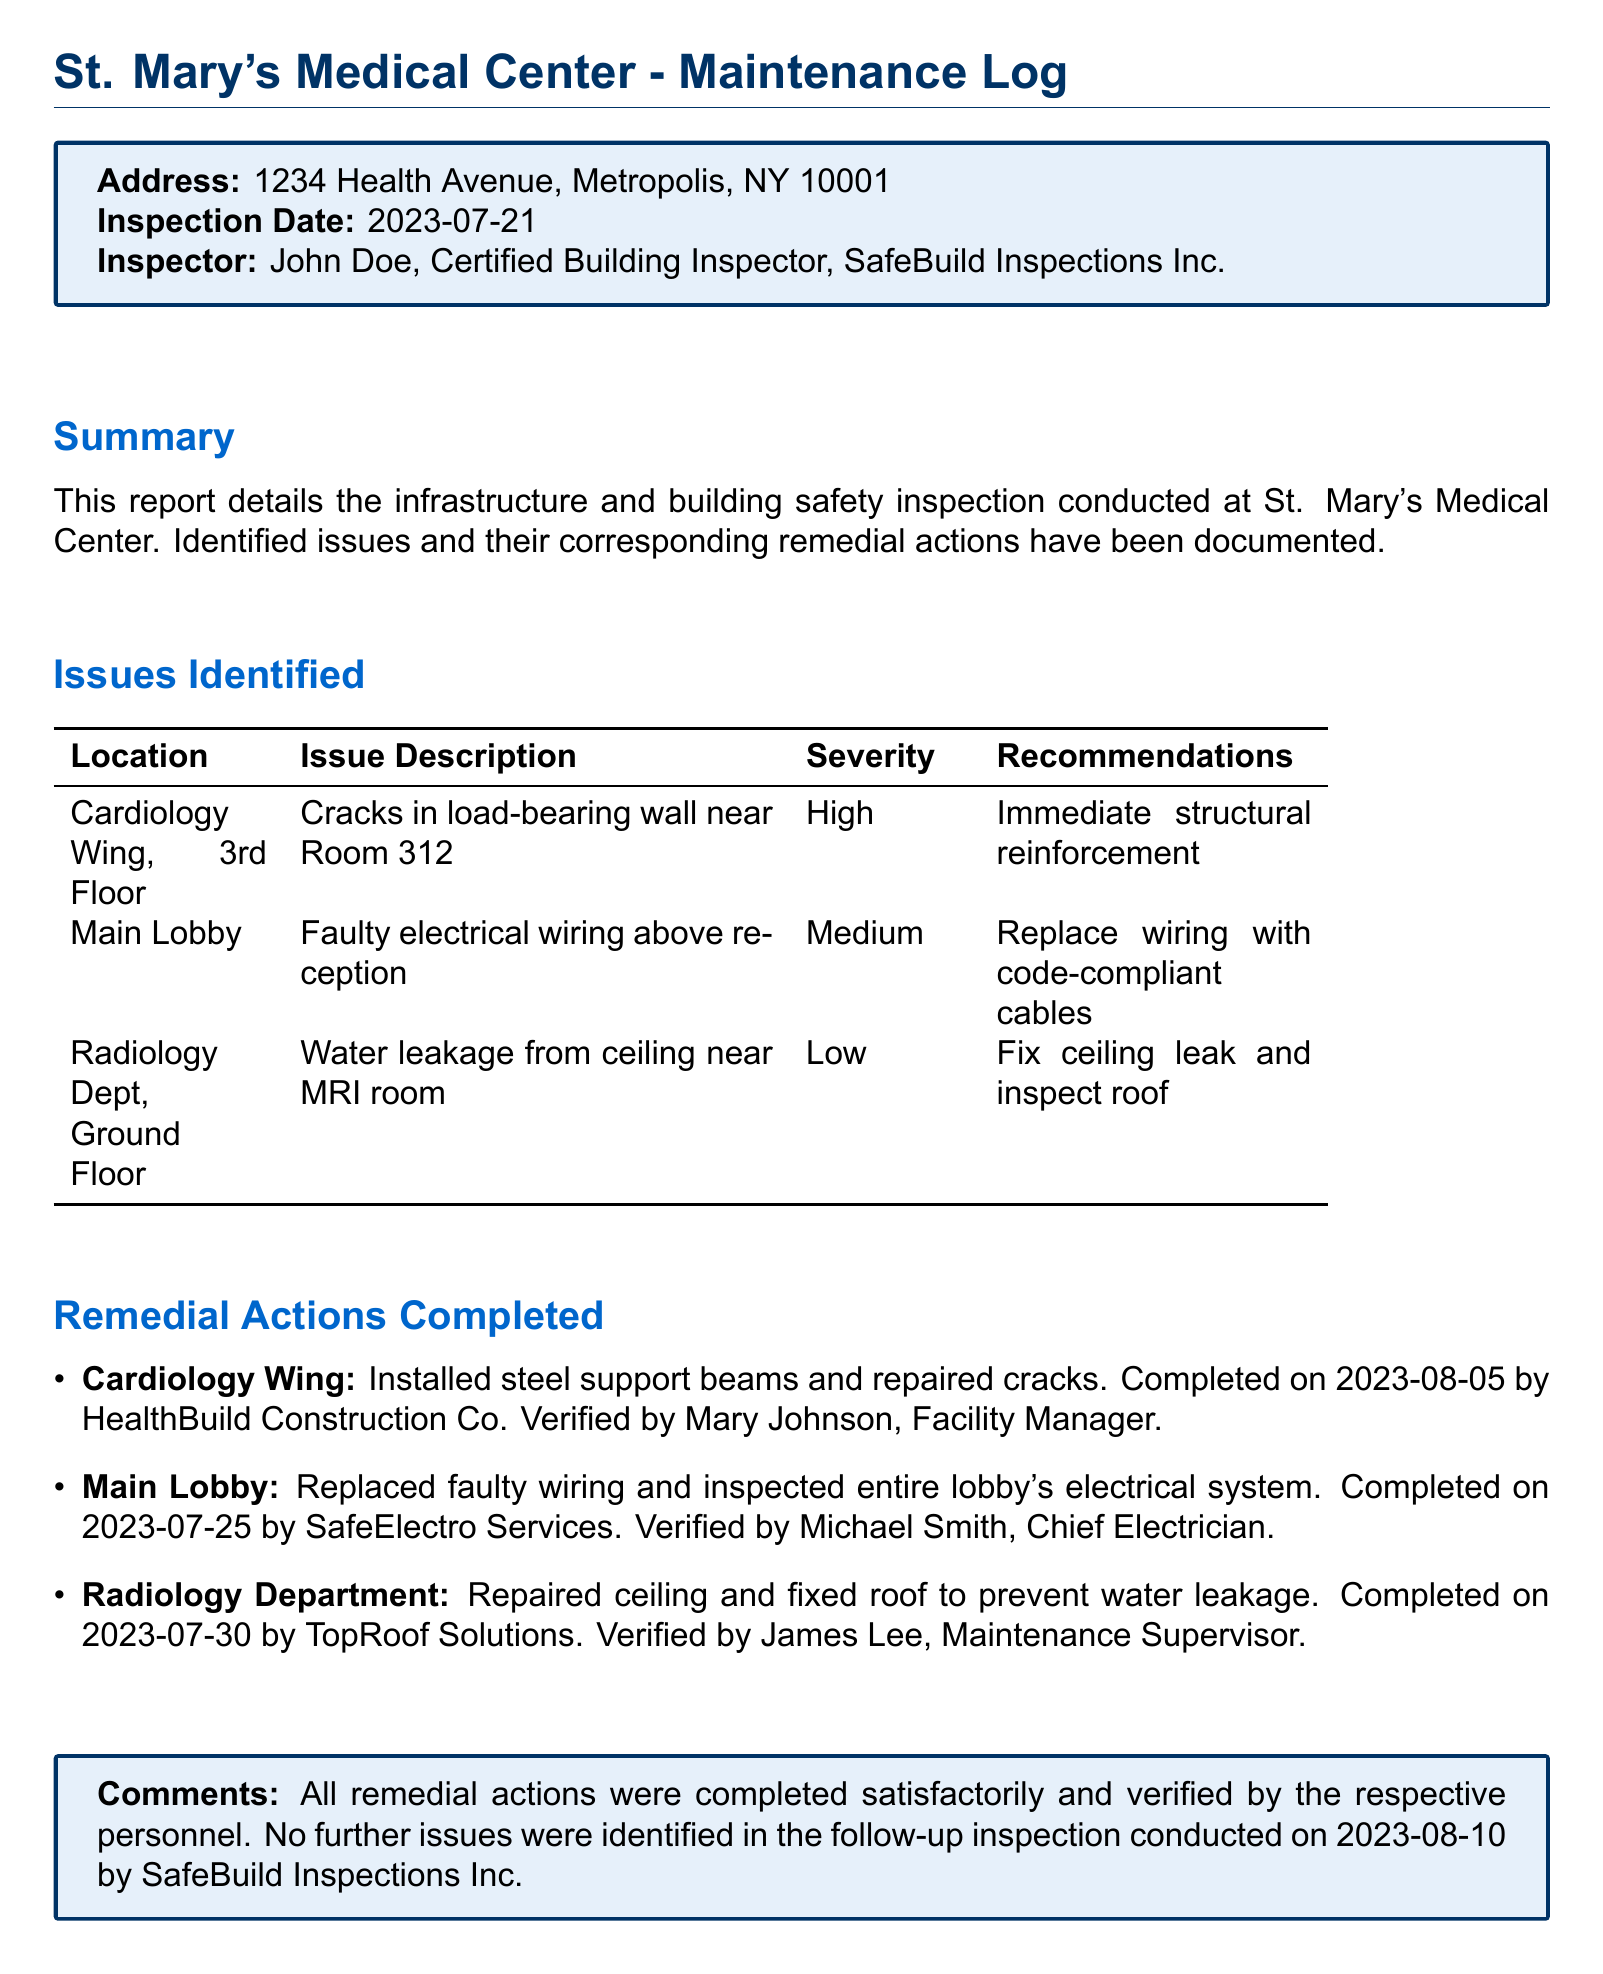What is the inspection date? The inspection date is specified in the document as the date when the inspection was conducted.
Answer: 2023-07-21 Who conducted the inspection? The inspector's name is noted at the beginning of the report, indicating who performed the inspection.
Answer: John Doe What issue was found in the Cardiology Wing? The issue description includes specific problems identified in several locations, including the Cardiology Wing.
Answer: Cracks in load-bearing wall near Room 312 What was the severity level of the faulty electrical wiring? The severity levels of the identified issues are classified in the document, giving insight into the urgency of the problems.
Answer: Medium What remedial action was taken in the Radiology Department? The completed remedial actions provide details on how each identified issue was resolved, particularly in the Radiology Department.
Answer: Repaired ceiling and fixed roof to prevent water leakage When was the ceiling leak in the Radiology Department fixed? The completion date for the remedial action provides the timeline of when issues were addressed.
Answer: 2023-07-30 How many issues were identified in total? Counting the issues listed in the "Issues Identified" section gives the total number of problems found during the inspection.
Answer: 3 What company handled the repairs in the Cardiology Wing? The document specifies which company was responsible for each completed remedial action, particularly in the Cardiology Wing.
Answer: HealthBuild Construction Co Who verified the work done in the Main Lobby? The document mentions the personnel responsible for verifying the completion of remedial actions in different sections of the facility.
Answer: Michael Smith 